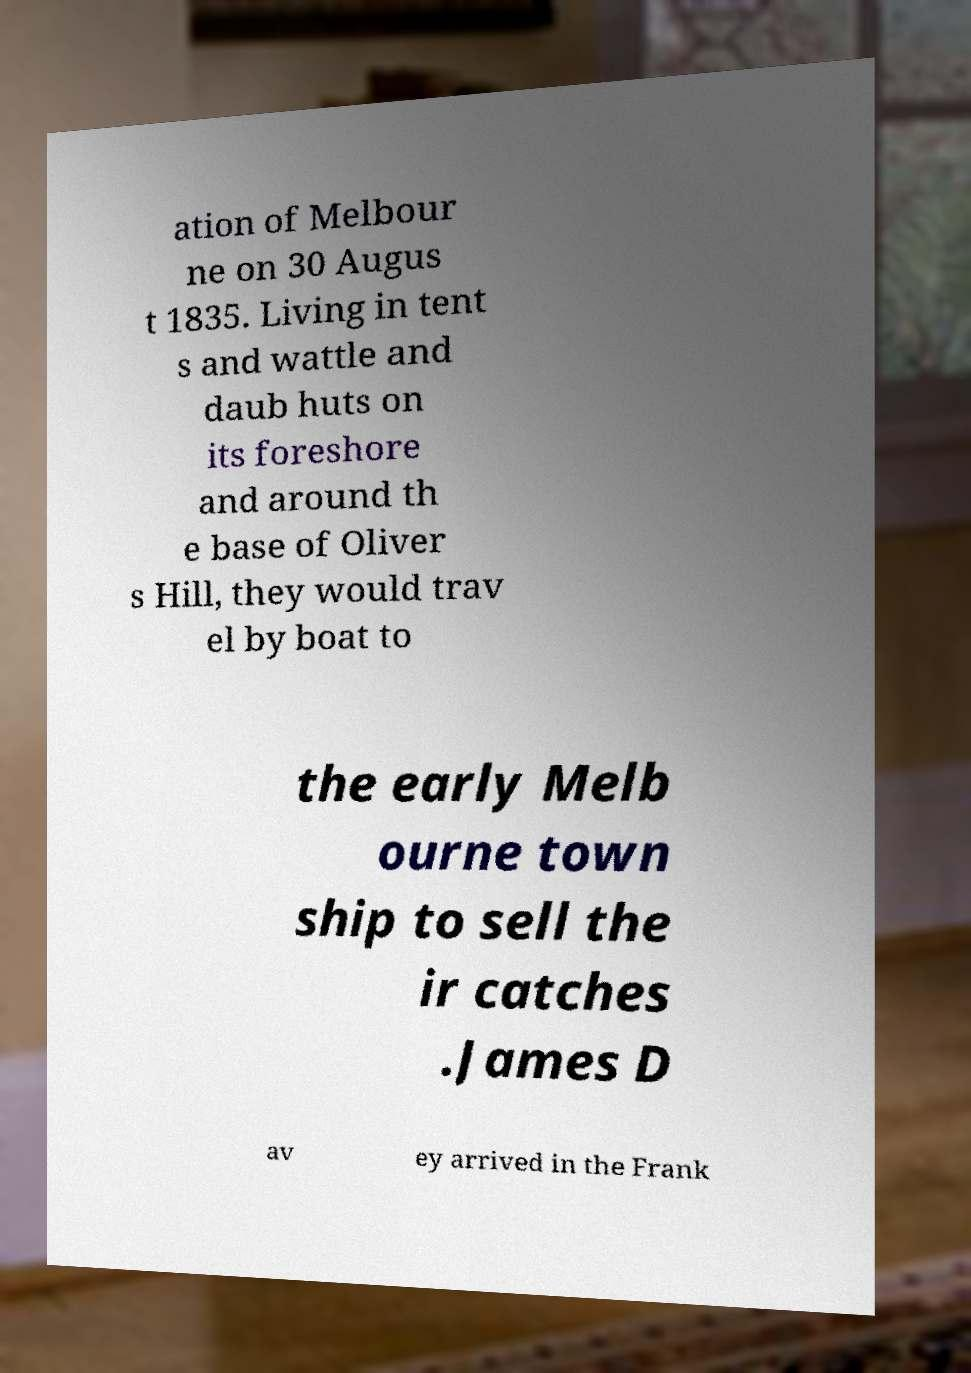For documentation purposes, I need the text within this image transcribed. Could you provide that? ation of Melbour ne on 30 Augus t 1835. Living in tent s and wattle and daub huts on its foreshore and around th e base of Oliver s Hill, they would trav el by boat to the early Melb ourne town ship to sell the ir catches .James D av ey arrived in the Frank 